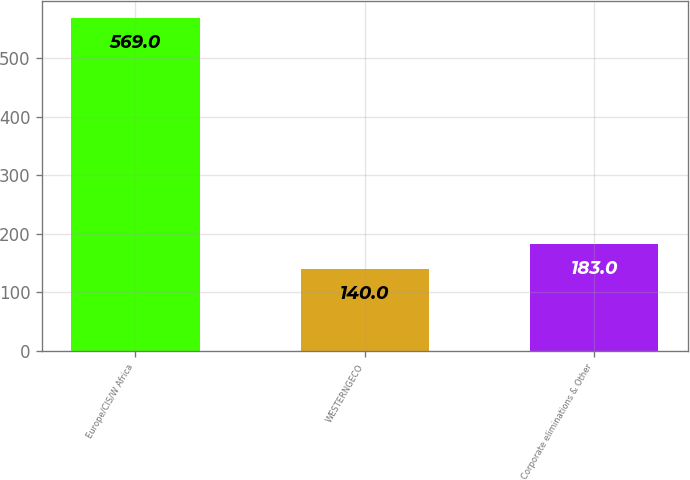Convert chart. <chart><loc_0><loc_0><loc_500><loc_500><bar_chart><fcel>Europe/CIS/W Africa<fcel>WESTERNGECO<fcel>Corporate eliminations & Other<nl><fcel>569<fcel>140<fcel>183<nl></chart> 